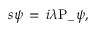<formula> <loc_0><loc_0><loc_500><loc_500>s \psi \, = \, i \lambda P _ { - } \psi ,</formula> 